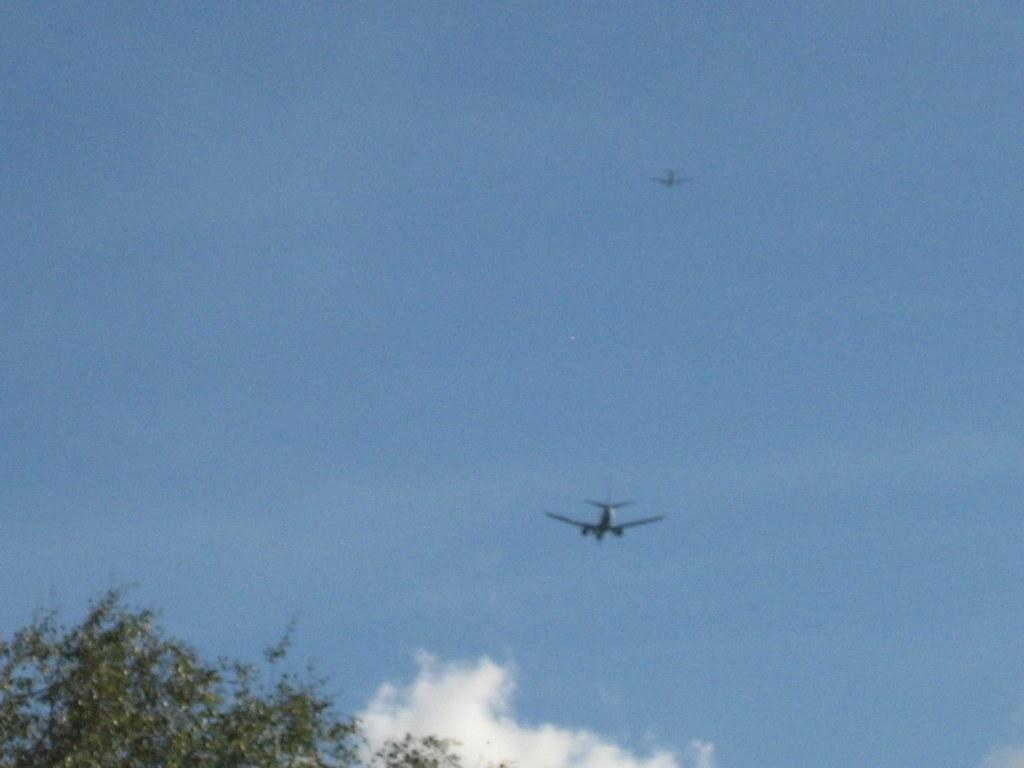What is happening in the sky in the image? There are aeroplanes flying in the sky in the image. What can be seen at the bottom of the image? There is a tree at the bottom of the image. What else is visible in the sky besides the aeroplanes? Clouds are present in the sky in the image. Where can the crown be found in the image? There is no crown present in the image. What type of plantation is visible in the image? There is no plantation visible in the image. 